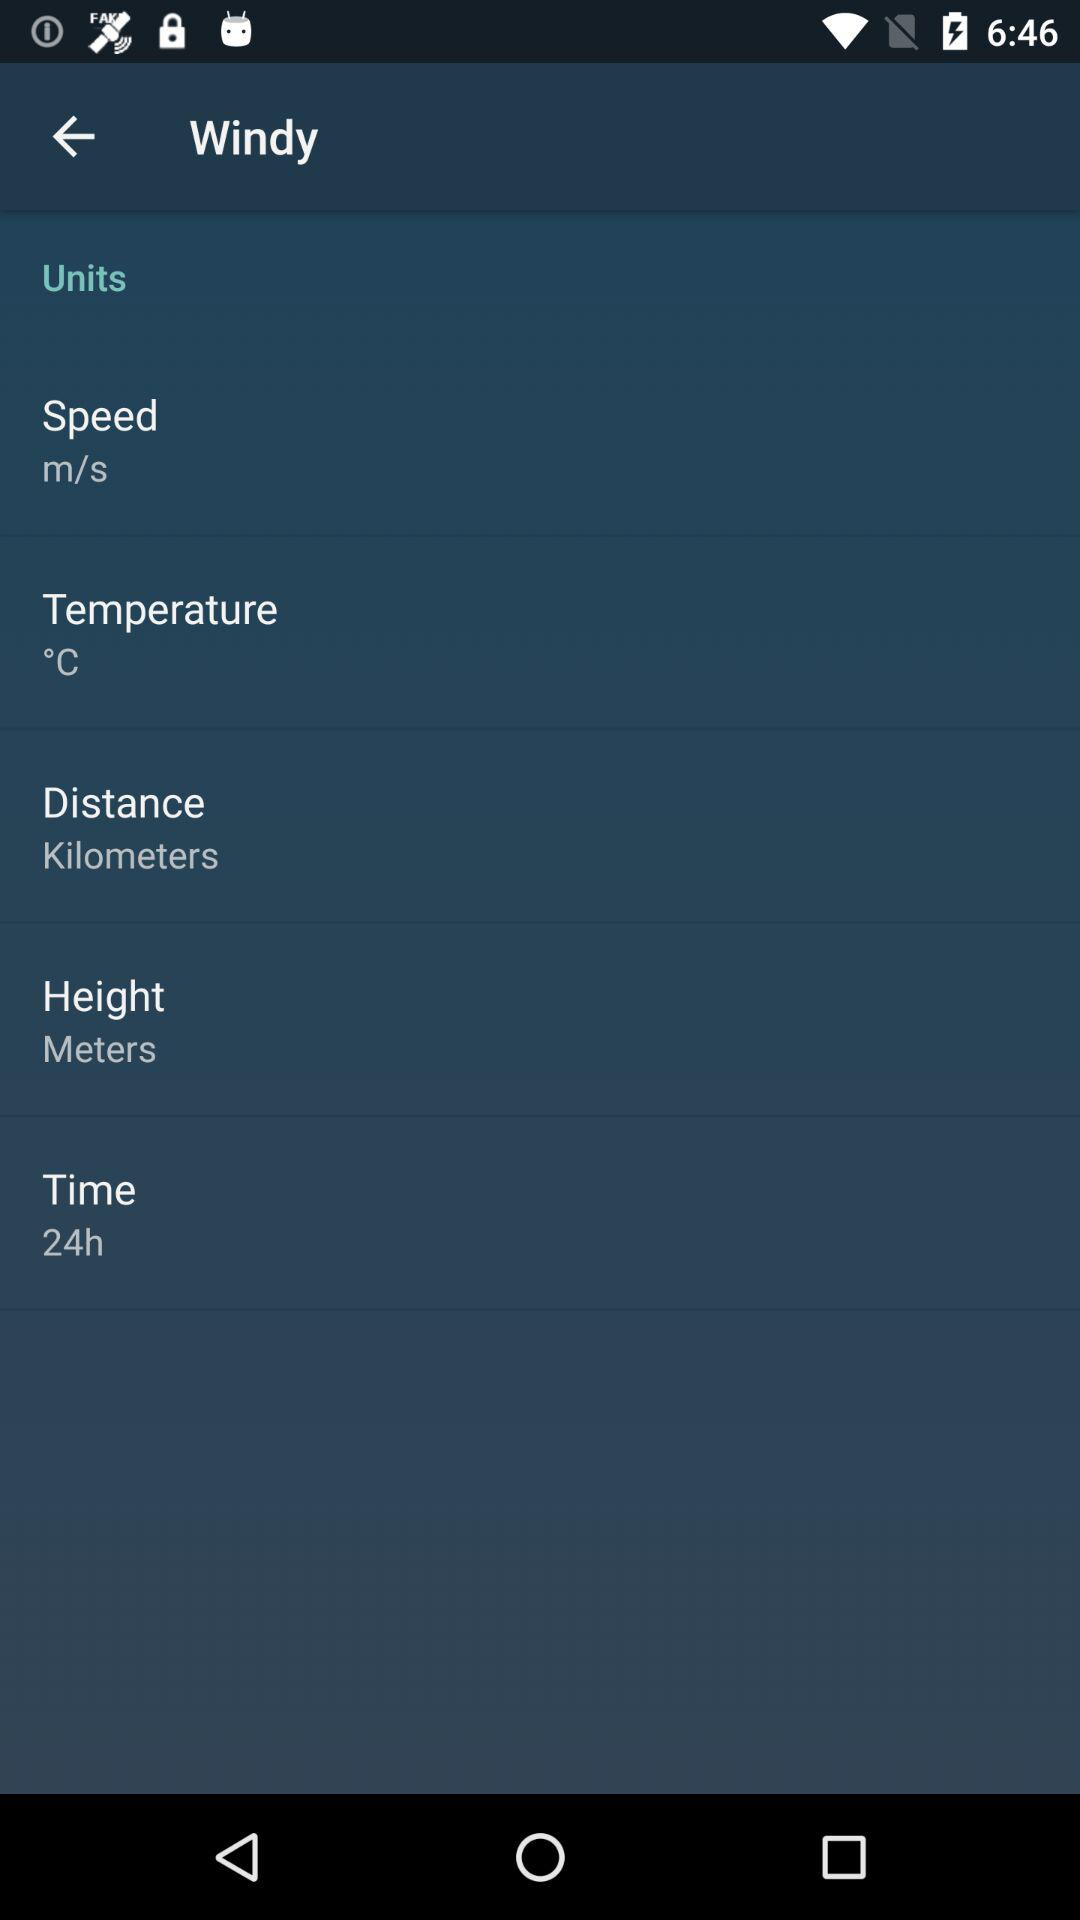What is the given unit of height? The given unit of height is the meter. 